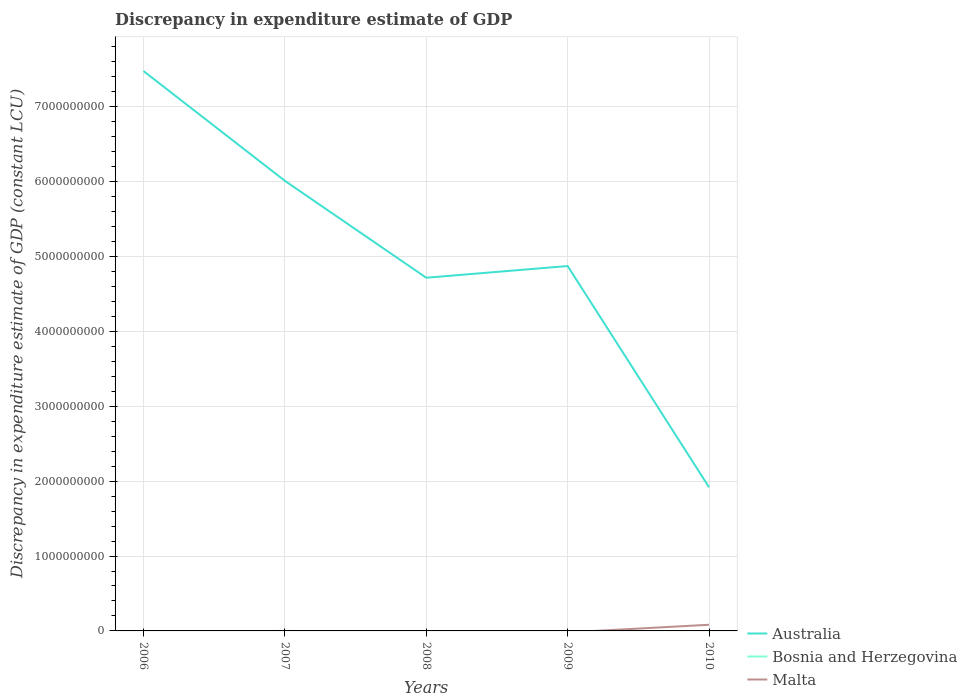What is the total discrepancy in expenditure estimate of GDP in Australia in the graph?
Provide a succinct answer. 1.14e+09. What is the difference between the highest and the second highest discrepancy in expenditure estimate of GDP in Australia?
Keep it short and to the point. 5.56e+09. Is the discrepancy in expenditure estimate of GDP in Bosnia and Herzegovina strictly greater than the discrepancy in expenditure estimate of GDP in Australia over the years?
Offer a terse response. Yes. How many lines are there?
Ensure brevity in your answer.  2. What is the difference between two consecutive major ticks on the Y-axis?
Your response must be concise. 1.00e+09. Does the graph contain any zero values?
Your answer should be very brief. Yes. What is the title of the graph?
Make the answer very short. Discrepancy in expenditure estimate of GDP. Does "Ghana" appear as one of the legend labels in the graph?
Offer a very short reply. No. What is the label or title of the Y-axis?
Keep it short and to the point. Discrepancy in expenditure estimate of GDP (constant LCU). What is the Discrepancy in expenditure estimate of GDP (constant LCU) of Australia in 2006?
Your answer should be compact. 7.48e+09. What is the Discrepancy in expenditure estimate of GDP (constant LCU) of Bosnia and Herzegovina in 2006?
Offer a terse response. 0. What is the Discrepancy in expenditure estimate of GDP (constant LCU) in Malta in 2006?
Keep it short and to the point. 0. What is the Discrepancy in expenditure estimate of GDP (constant LCU) in Australia in 2007?
Your answer should be very brief. 6.01e+09. What is the Discrepancy in expenditure estimate of GDP (constant LCU) in Australia in 2008?
Make the answer very short. 4.72e+09. What is the Discrepancy in expenditure estimate of GDP (constant LCU) in Bosnia and Herzegovina in 2008?
Offer a very short reply. 0. What is the Discrepancy in expenditure estimate of GDP (constant LCU) of Australia in 2009?
Offer a very short reply. 4.87e+09. What is the Discrepancy in expenditure estimate of GDP (constant LCU) of Australia in 2010?
Ensure brevity in your answer.  1.92e+09. What is the Discrepancy in expenditure estimate of GDP (constant LCU) of Bosnia and Herzegovina in 2010?
Make the answer very short. 0. What is the Discrepancy in expenditure estimate of GDP (constant LCU) in Malta in 2010?
Make the answer very short. 8.23e+07. Across all years, what is the maximum Discrepancy in expenditure estimate of GDP (constant LCU) of Australia?
Ensure brevity in your answer.  7.48e+09. Across all years, what is the maximum Discrepancy in expenditure estimate of GDP (constant LCU) in Malta?
Provide a succinct answer. 8.23e+07. Across all years, what is the minimum Discrepancy in expenditure estimate of GDP (constant LCU) of Australia?
Keep it short and to the point. 1.92e+09. Across all years, what is the minimum Discrepancy in expenditure estimate of GDP (constant LCU) in Malta?
Provide a short and direct response. 0. What is the total Discrepancy in expenditure estimate of GDP (constant LCU) in Australia in the graph?
Your answer should be compact. 2.50e+1. What is the total Discrepancy in expenditure estimate of GDP (constant LCU) in Bosnia and Herzegovina in the graph?
Make the answer very short. 0. What is the total Discrepancy in expenditure estimate of GDP (constant LCU) of Malta in the graph?
Offer a terse response. 8.23e+07. What is the difference between the Discrepancy in expenditure estimate of GDP (constant LCU) in Australia in 2006 and that in 2007?
Give a very brief answer. 1.47e+09. What is the difference between the Discrepancy in expenditure estimate of GDP (constant LCU) of Australia in 2006 and that in 2008?
Your answer should be very brief. 2.76e+09. What is the difference between the Discrepancy in expenditure estimate of GDP (constant LCU) of Australia in 2006 and that in 2009?
Provide a succinct answer. 2.60e+09. What is the difference between the Discrepancy in expenditure estimate of GDP (constant LCU) of Australia in 2006 and that in 2010?
Offer a very short reply. 5.56e+09. What is the difference between the Discrepancy in expenditure estimate of GDP (constant LCU) of Australia in 2007 and that in 2008?
Keep it short and to the point. 1.29e+09. What is the difference between the Discrepancy in expenditure estimate of GDP (constant LCU) in Australia in 2007 and that in 2009?
Offer a very short reply. 1.14e+09. What is the difference between the Discrepancy in expenditure estimate of GDP (constant LCU) in Australia in 2007 and that in 2010?
Provide a short and direct response. 4.09e+09. What is the difference between the Discrepancy in expenditure estimate of GDP (constant LCU) of Australia in 2008 and that in 2009?
Your response must be concise. -1.56e+08. What is the difference between the Discrepancy in expenditure estimate of GDP (constant LCU) in Australia in 2008 and that in 2010?
Make the answer very short. 2.80e+09. What is the difference between the Discrepancy in expenditure estimate of GDP (constant LCU) of Australia in 2009 and that in 2010?
Your response must be concise. 2.95e+09. What is the difference between the Discrepancy in expenditure estimate of GDP (constant LCU) of Australia in 2006 and the Discrepancy in expenditure estimate of GDP (constant LCU) of Malta in 2010?
Keep it short and to the point. 7.39e+09. What is the difference between the Discrepancy in expenditure estimate of GDP (constant LCU) in Australia in 2007 and the Discrepancy in expenditure estimate of GDP (constant LCU) in Malta in 2010?
Your response must be concise. 5.93e+09. What is the difference between the Discrepancy in expenditure estimate of GDP (constant LCU) in Australia in 2008 and the Discrepancy in expenditure estimate of GDP (constant LCU) in Malta in 2010?
Offer a very short reply. 4.63e+09. What is the difference between the Discrepancy in expenditure estimate of GDP (constant LCU) of Australia in 2009 and the Discrepancy in expenditure estimate of GDP (constant LCU) of Malta in 2010?
Make the answer very short. 4.79e+09. What is the average Discrepancy in expenditure estimate of GDP (constant LCU) of Australia per year?
Your response must be concise. 5.00e+09. What is the average Discrepancy in expenditure estimate of GDP (constant LCU) in Malta per year?
Your answer should be very brief. 1.65e+07. In the year 2010, what is the difference between the Discrepancy in expenditure estimate of GDP (constant LCU) of Australia and Discrepancy in expenditure estimate of GDP (constant LCU) of Malta?
Your answer should be very brief. 1.84e+09. What is the ratio of the Discrepancy in expenditure estimate of GDP (constant LCU) of Australia in 2006 to that in 2007?
Offer a very short reply. 1.24. What is the ratio of the Discrepancy in expenditure estimate of GDP (constant LCU) of Australia in 2006 to that in 2008?
Your answer should be compact. 1.59. What is the ratio of the Discrepancy in expenditure estimate of GDP (constant LCU) of Australia in 2006 to that in 2009?
Provide a succinct answer. 1.53. What is the ratio of the Discrepancy in expenditure estimate of GDP (constant LCU) of Australia in 2006 to that in 2010?
Provide a succinct answer. 3.9. What is the ratio of the Discrepancy in expenditure estimate of GDP (constant LCU) of Australia in 2007 to that in 2008?
Your response must be concise. 1.27. What is the ratio of the Discrepancy in expenditure estimate of GDP (constant LCU) of Australia in 2007 to that in 2009?
Offer a terse response. 1.23. What is the ratio of the Discrepancy in expenditure estimate of GDP (constant LCU) in Australia in 2007 to that in 2010?
Your answer should be very brief. 3.13. What is the ratio of the Discrepancy in expenditure estimate of GDP (constant LCU) of Australia in 2008 to that in 2010?
Offer a terse response. 2.46. What is the ratio of the Discrepancy in expenditure estimate of GDP (constant LCU) of Australia in 2009 to that in 2010?
Your answer should be very brief. 2.54. What is the difference between the highest and the second highest Discrepancy in expenditure estimate of GDP (constant LCU) of Australia?
Keep it short and to the point. 1.47e+09. What is the difference between the highest and the lowest Discrepancy in expenditure estimate of GDP (constant LCU) of Australia?
Offer a terse response. 5.56e+09. What is the difference between the highest and the lowest Discrepancy in expenditure estimate of GDP (constant LCU) of Malta?
Your response must be concise. 8.23e+07. 